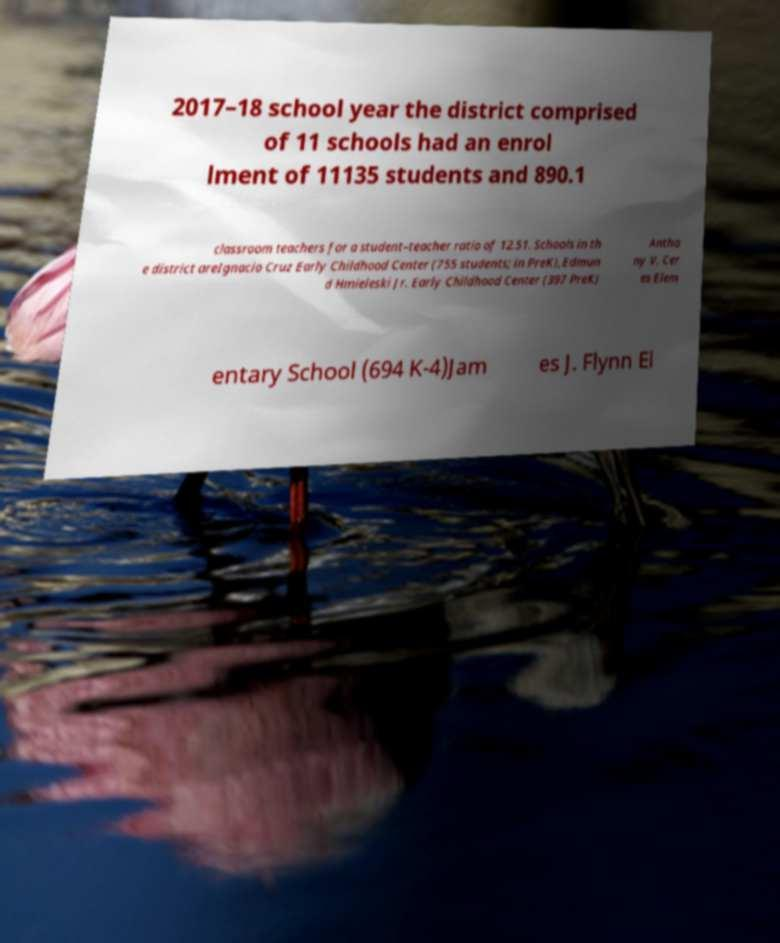Please identify and transcribe the text found in this image. 2017–18 school year the district comprised of 11 schools had an enrol lment of 11135 students and 890.1 classroom teachers for a student–teacher ratio of 12.51. Schools in th e district areIgnacio Cruz Early Childhood Center (755 students; in PreK),Edmun d Hmieleski Jr. Early Childhood Center (397 PreK) Antho ny V. Cer es Elem entary School (694 K-4)Jam es J. Flynn El 